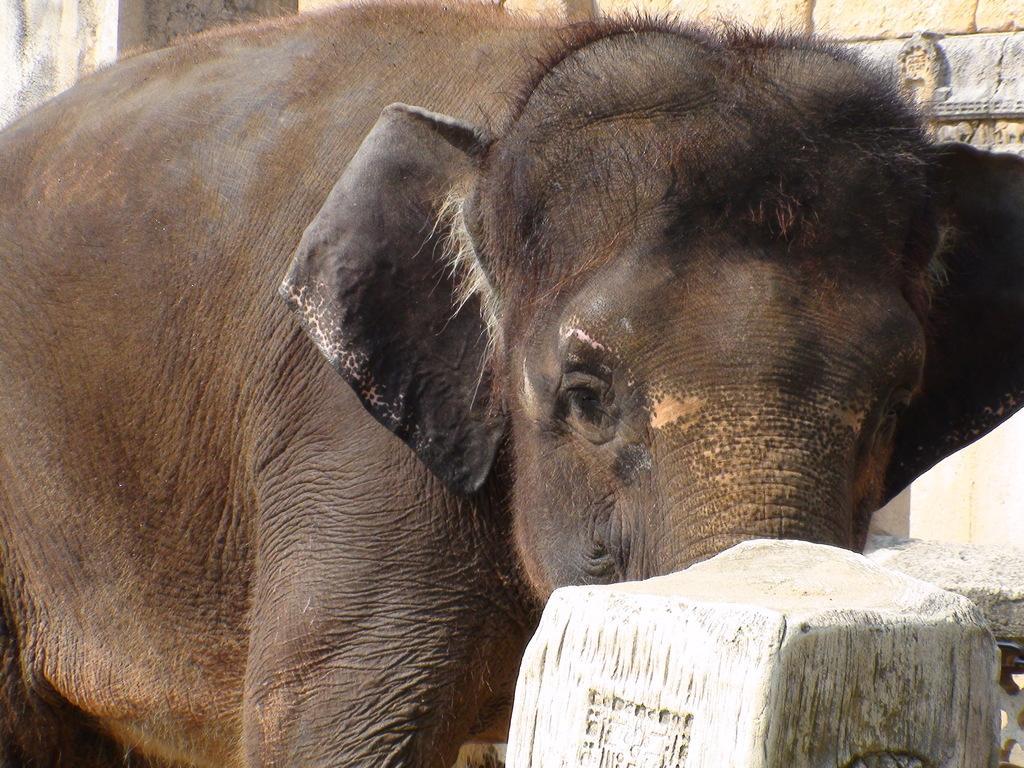How would you summarize this image in a sentence or two? In the center of the image we can see elephant. In the background there is wall. 